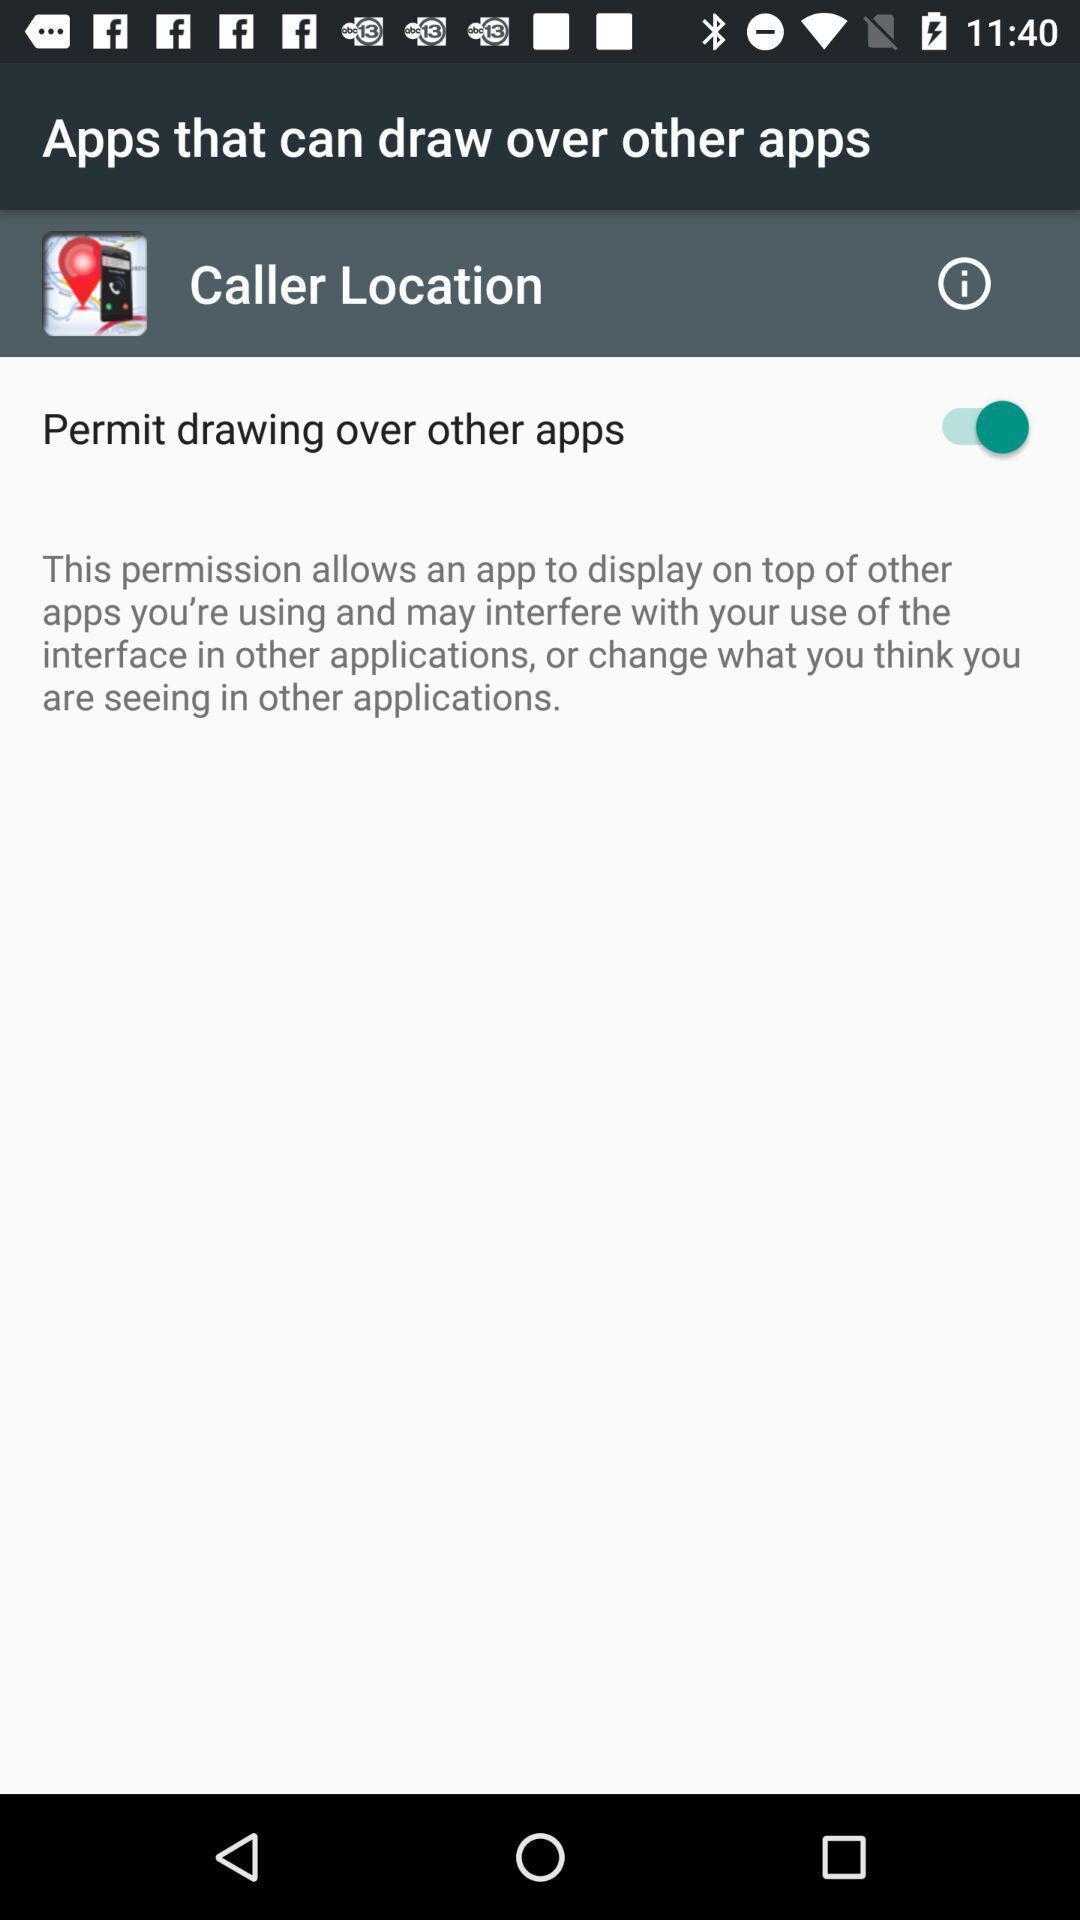Provide a textual representation of this image. Permission enable page in a location tracker app. 